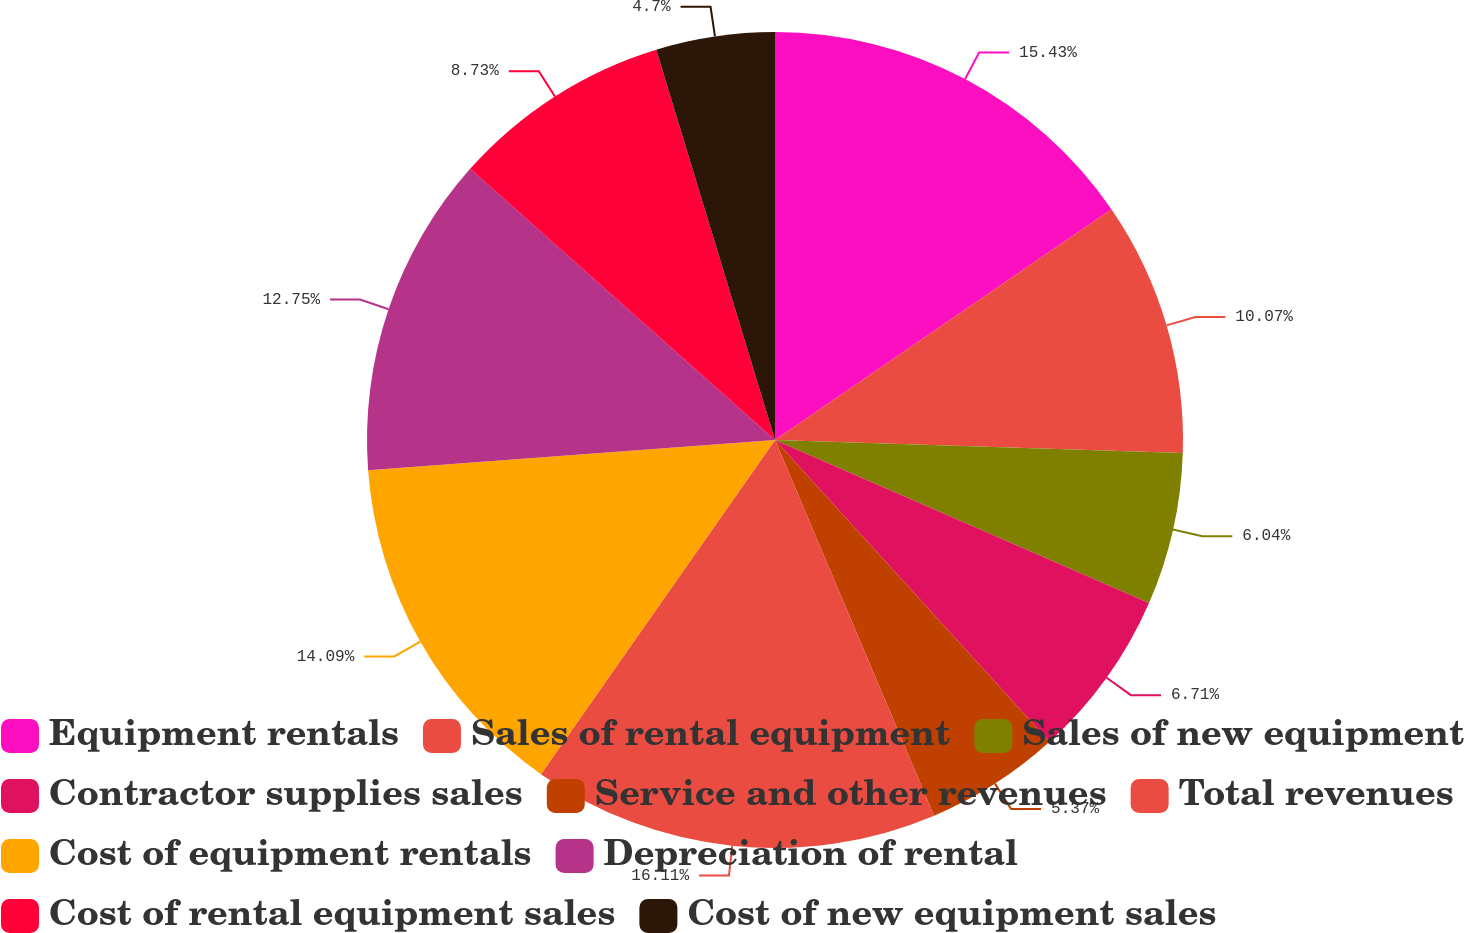Convert chart to OTSL. <chart><loc_0><loc_0><loc_500><loc_500><pie_chart><fcel>Equipment rentals<fcel>Sales of rental equipment<fcel>Sales of new equipment<fcel>Contractor supplies sales<fcel>Service and other revenues<fcel>Total revenues<fcel>Cost of equipment rentals<fcel>Depreciation of rental<fcel>Cost of rental equipment sales<fcel>Cost of new equipment sales<nl><fcel>15.43%<fcel>10.07%<fcel>6.04%<fcel>6.71%<fcel>5.37%<fcel>16.1%<fcel>14.09%<fcel>12.75%<fcel>8.73%<fcel>4.7%<nl></chart> 